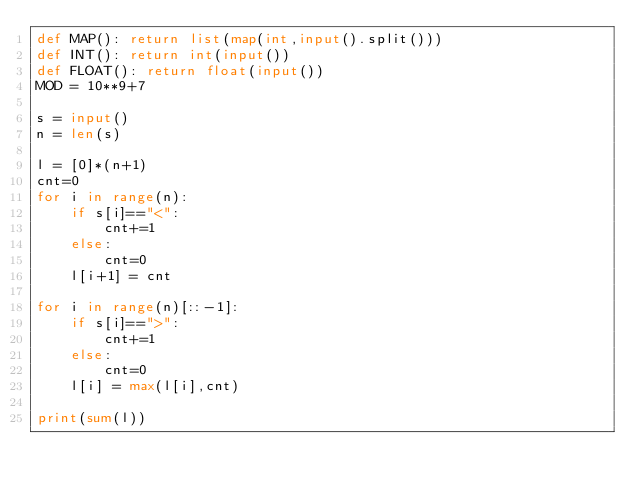Convert code to text. <code><loc_0><loc_0><loc_500><loc_500><_Python_>def MAP(): return list(map(int,input().split()))
def INT(): return int(input())
def FLOAT(): return float(input())
MOD = 10**9+7

s = input()
n = len(s)

l = [0]*(n+1)
cnt=0
for i in range(n):
    if s[i]=="<":
        cnt+=1
    else:
        cnt=0
    l[i+1] = cnt

for i in range(n)[::-1]:
    if s[i]==">":
        cnt+=1
    else:
        cnt=0
    l[i] = max(l[i],cnt)

print(sum(l))</code> 